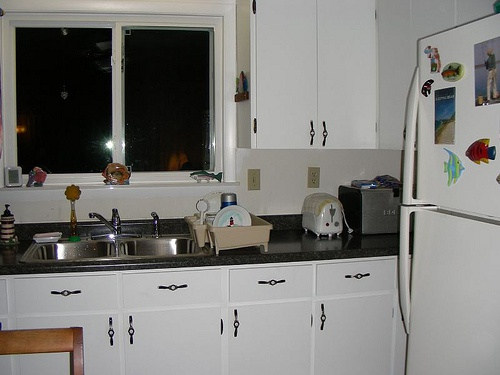Describe the objects in this image and their specific colors. I can see refrigerator in gray, darkgray, black, and maroon tones, chair in gray, maroon, and brown tones, toaster in gray and black tones, sink in gray, black, darkgray, and white tones, and sink in gray, black, and white tones in this image. 